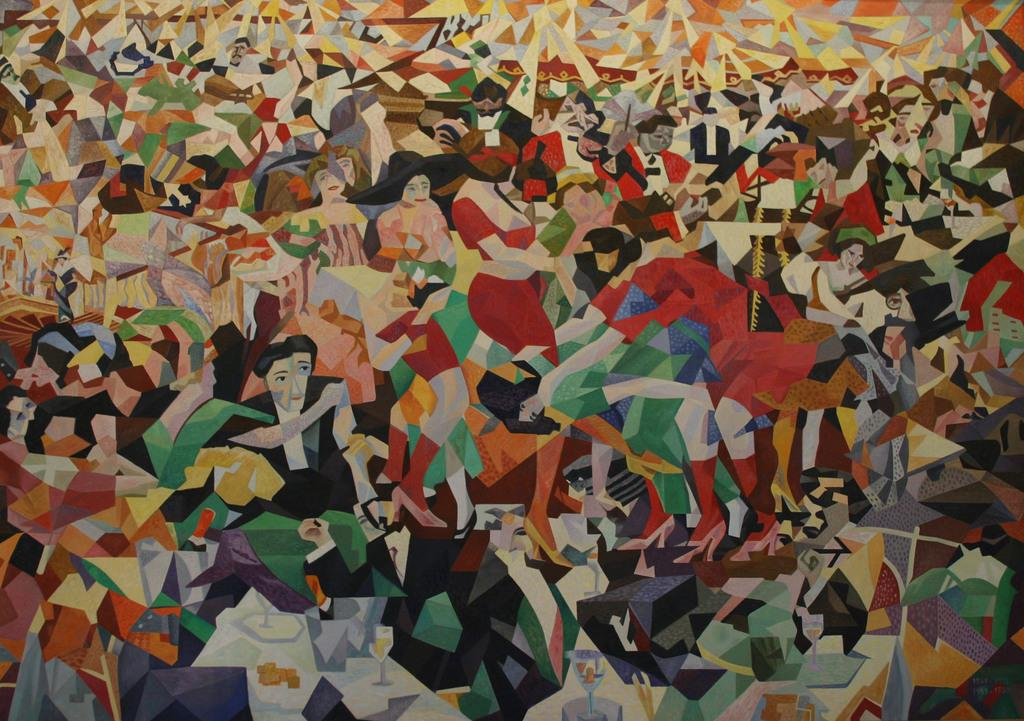What type of artwork is visible in the image? There are paintings in the image. What subjects are depicted in the paintings? The paintings depict people and objects. What type of learning is taking place in the image? There is no indication of learning taking place in the image; it only shows paintings depicting people and objects. 